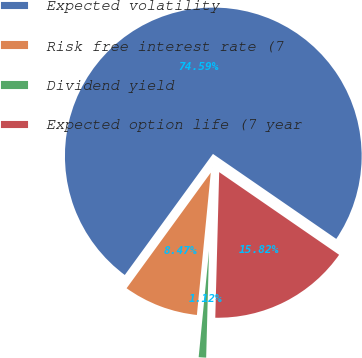Convert chart to OTSL. <chart><loc_0><loc_0><loc_500><loc_500><pie_chart><fcel>Expected volatility<fcel>Risk free interest rate (7<fcel>Dividend yield<fcel>Expected option life (7 year<nl><fcel>74.58%<fcel>8.47%<fcel>1.12%<fcel>15.82%<nl></chart> 